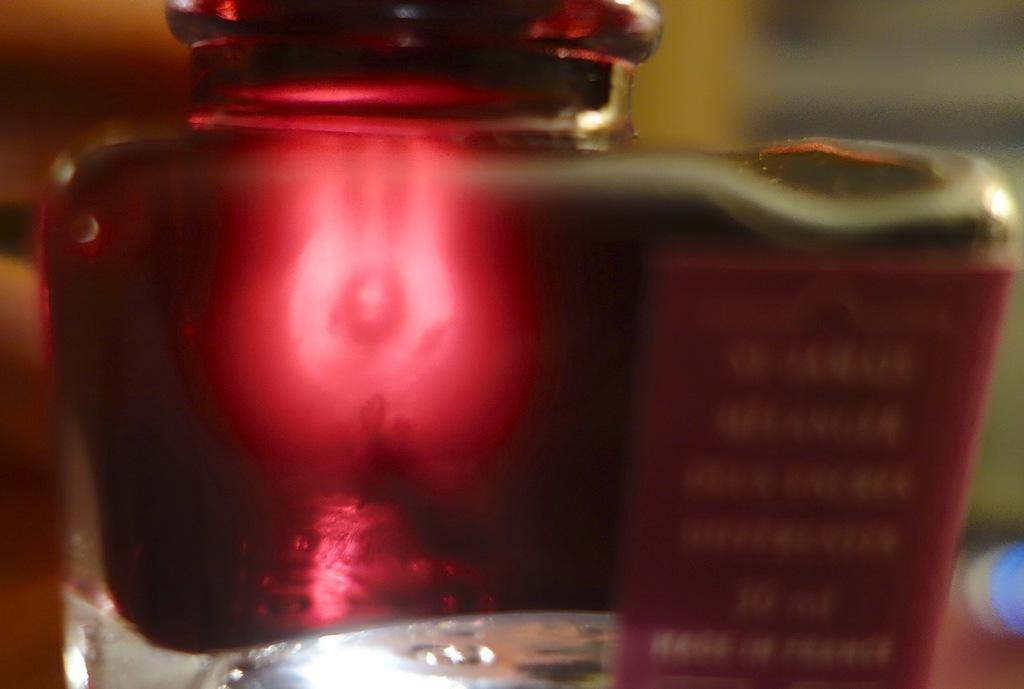What is the color of the bottle in the image? The bottle in the image is red. Is the bottle in the image capable of watching the sunset? The bottle in the image is not capable of watching the sunset, as it is an inanimate object and does not have the ability to see or perceive. 